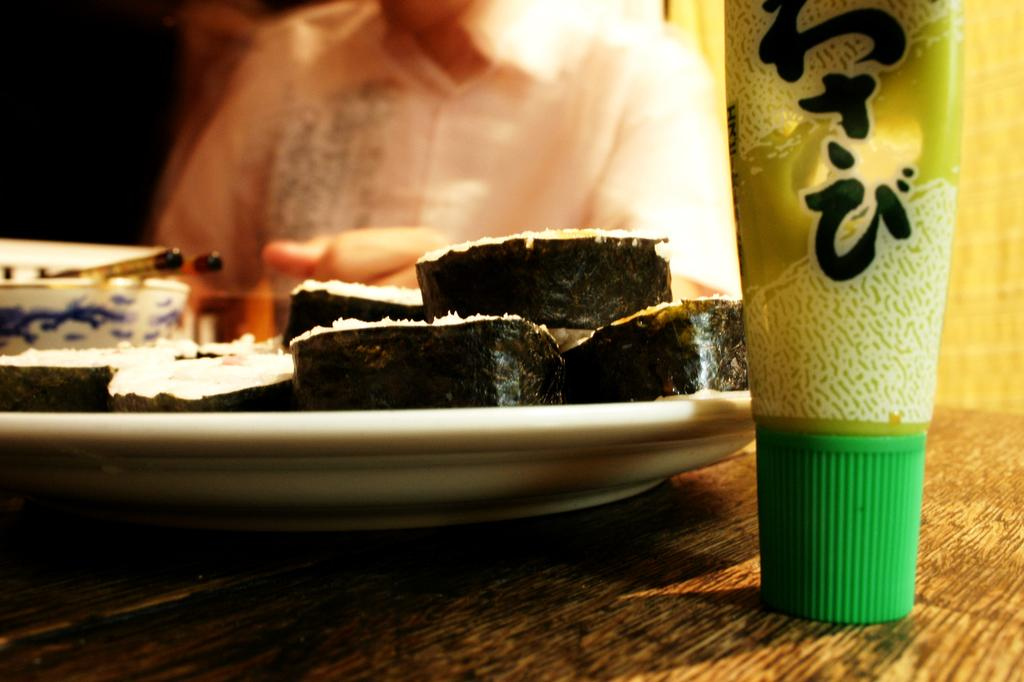What type of plate is used for the food items in the image? The food items are on a white color plate in the image. What else can be seen on the table besides the plate? There are objects on the table in the image. Can you describe the person visible in the background of the image? Unfortunately, the facts provided do not give any details about the person in the background. What type of branch is growing from the cemetery in the image? There is no cemetery or branch present in the image. 